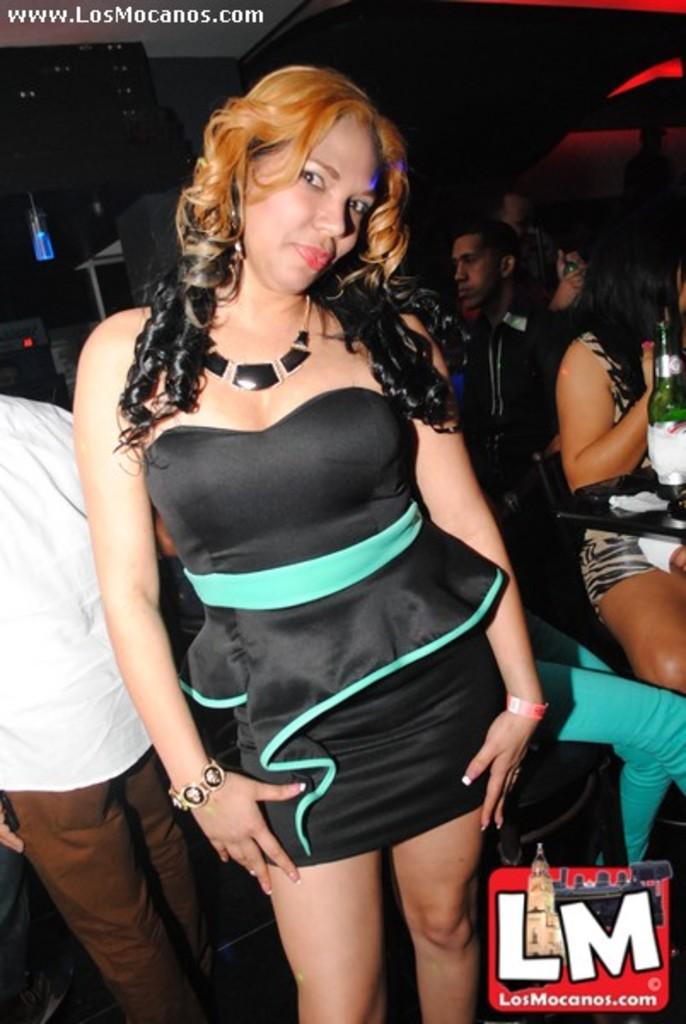Which website is advertised in the ad?
Give a very brief answer. Losmocanos.com. What's the website url at the top?
Make the answer very short. Www.losmocanos.com. 